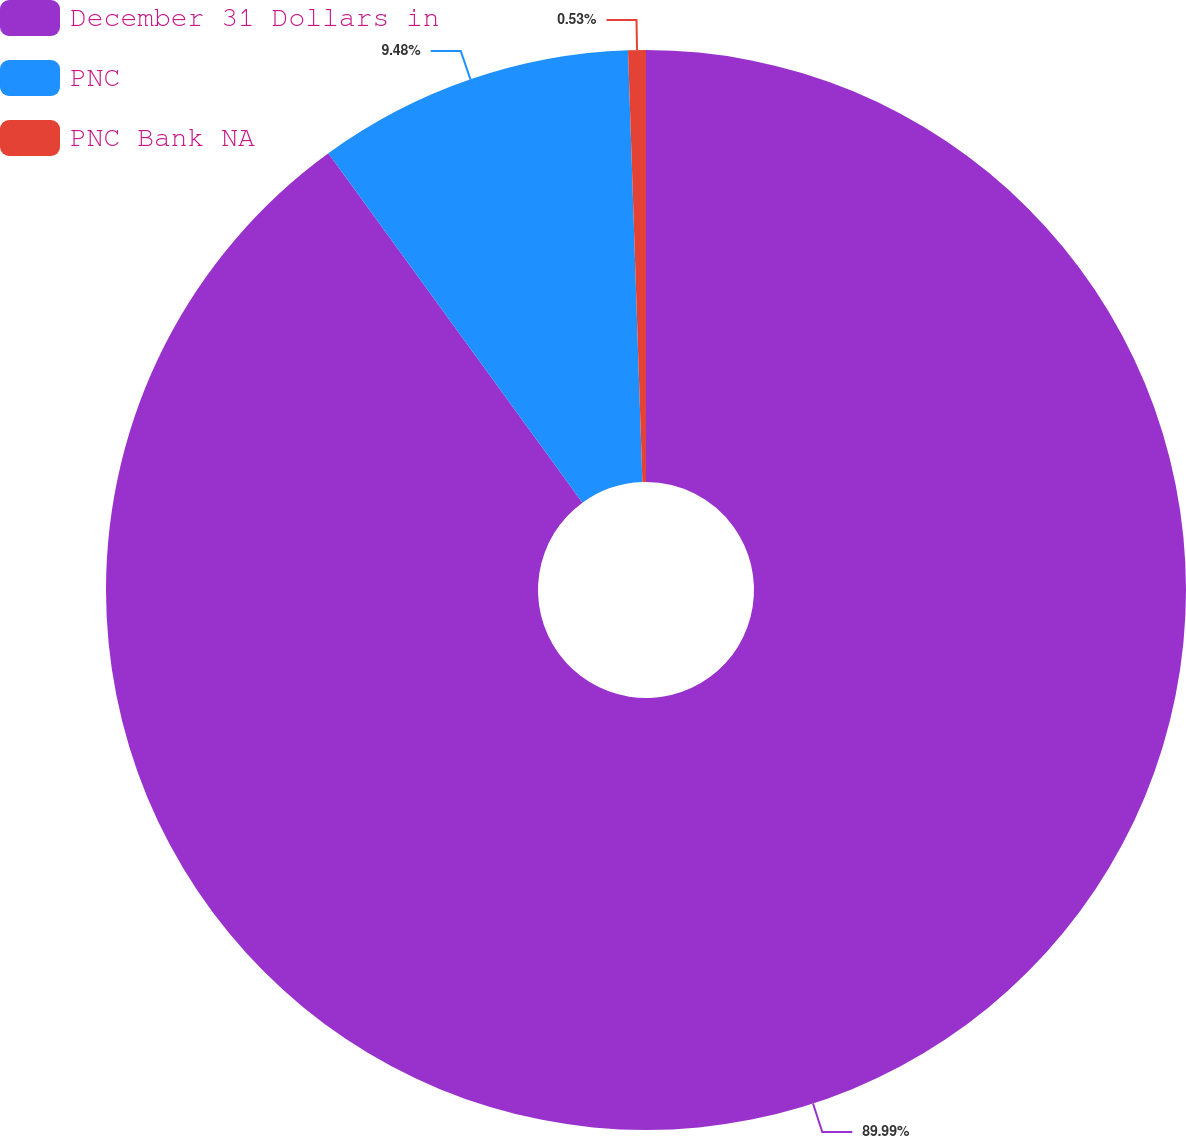<chart> <loc_0><loc_0><loc_500><loc_500><pie_chart><fcel>December 31 Dollars in<fcel>PNC<fcel>PNC Bank NA<nl><fcel>90.0%<fcel>9.48%<fcel>0.53%<nl></chart> 